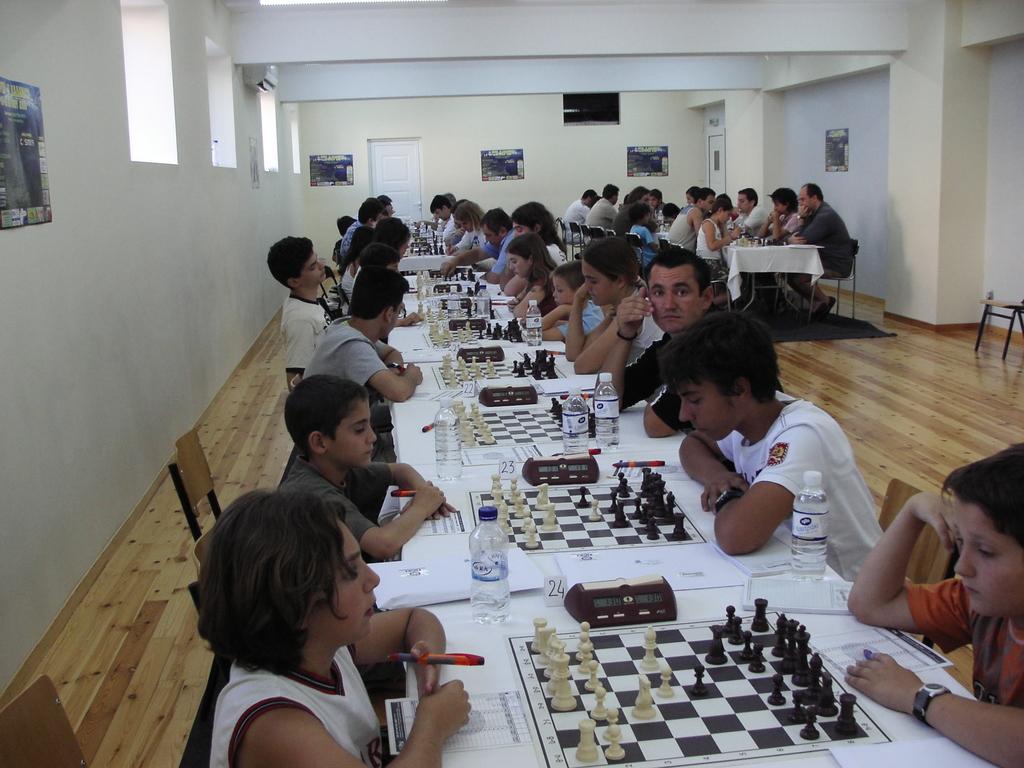How would you summarize this image in a sentence or two? This picture contains many tables and many chess boards placed on each table. In front of the picture, we see a table on which water bottle, paper, book are placed. There are many people sitting on chair beside these tables and on background, we see a wall on which photo frames are placed. To the the right top of the picture, we see pillar. 